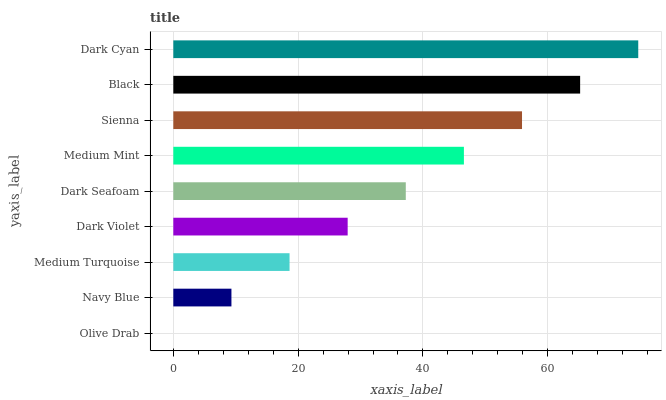Is Olive Drab the minimum?
Answer yes or no. Yes. Is Dark Cyan the maximum?
Answer yes or no. Yes. Is Navy Blue the minimum?
Answer yes or no. No. Is Navy Blue the maximum?
Answer yes or no. No. Is Navy Blue greater than Olive Drab?
Answer yes or no. Yes. Is Olive Drab less than Navy Blue?
Answer yes or no. Yes. Is Olive Drab greater than Navy Blue?
Answer yes or no. No. Is Navy Blue less than Olive Drab?
Answer yes or no. No. Is Dark Seafoam the high median?
Answer yes or no. Yes. Is Dark Seafoam the low median?
Answer yes or no. Yes. Is Olive Drab the high median?
Answer yes or no. No. Is Medium Mint the low median?
Answer yes or no. No. 